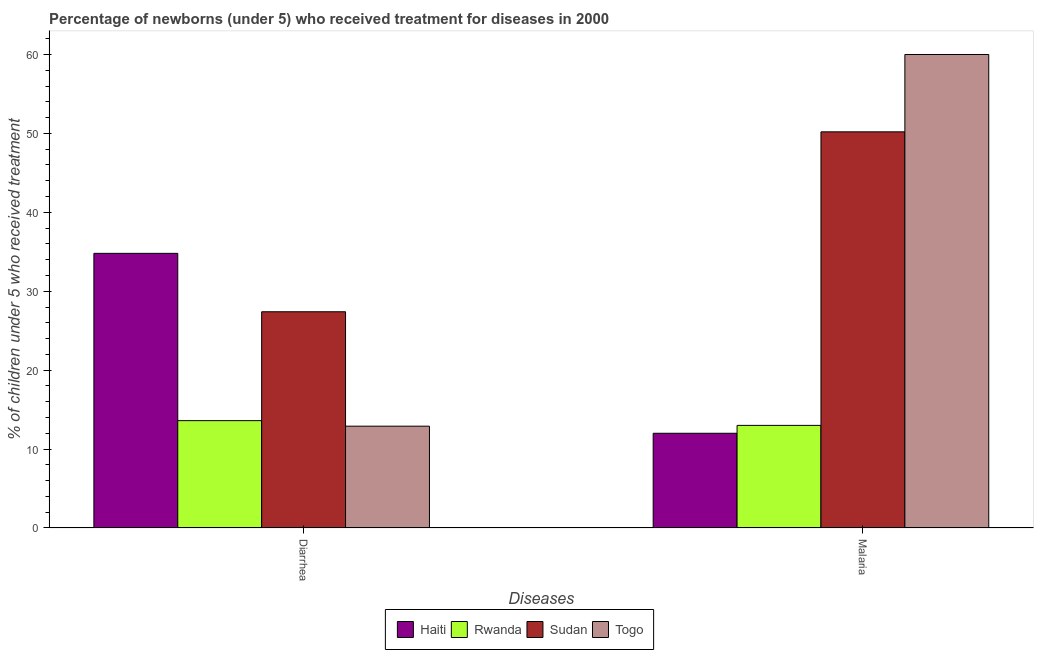Are the number of bars per tick equal to the number of legend labels?
Ensure brevity in your answer.  Yes. What is the label of the 1st group of bars from the left?
Ensure brevity in your answer.  Diarrhea. What is the percentage of children who received treatment for malaria in Togo?
Offer a terse response. 60. Across all countries, what is the maximum percentage of children who received treatment for malaria?
Offer a terse response. 60. In which country was the percentage of children who received treatment for diarrhoea maximum?
Keep it short and to the point. Haiti. In which country was the percentage of children who received treatment for diarrhoea minimum?
Give a very brief answer. Togo. What is the total percentage of children who received treatment for diarrhoea in the graph?
Give a very brief answer. 88.7. What is the difference between the percentage of children who received treatment for diarrhoea in Haiti and that in Sudan?
Provide a succinct answer. 7.4. What is the difference between the percentage of children who received treatment for diarrhoea in Sudan and the percentage of children who received treatment for malaria in Togo?
Offer a very short reply. -32.6. What is the average percentage of children who received treatment for malaria per country?
Offer a very short reply. 33.8. What is the difference between the percentage of children who received treatment for diarrhoea and percentage of children who received treatment for malaria in Rwanda?
Your response must be concise. 0.6. In how many countries, is the percentage of children who received treatment for malaria greater than 6 %?
Make the answer very short. 4. What is the ratio of the percentage of children who received treatment for diarrhoea in Sudan to that in Togo?
Ensure brevity in your answer.  2.12. In how many countries, is the percentage of children who received treatment for diarrhoea greater than the average percentage of children who received treatment for diarrhoea taken over all countries?
Provide a succinct answer. 2. What does the 1st bar from the left in Diarrhea represents?
Provide a succinct answer. Haiti. What does the 4th bar from the right in Malaria represents?
Your response must be concise. Haiti. How many countries are there in the graph?
Give a very brief answer. 4. Are the values on the major ticks of Y-axis written in scientific E-notation?
Your answer should be compact. No. Does the graph contain grids?
Offer a very short reply. No. What is the title of the graph?
Provide a short and direct response. Percentage of newborns (under 5) who received treatment for diseases in 2000. What is the label or title of the X-axis?
Provide a short and direct response. Diseases. What is the label or title of the Y-axis?
Provide a short and direct response. % of children under 5 who received treatment. What is the % of children under 5 who received treatment in Haiti in Diarrhea?
Provide a short and direct response. 34.8. What is the % of children under 5 who received treatment in Sudan in Diarrhea?
Provide a short and direct response. 27.4. What is the % of children under 5 who received treatment of Sudan in Malaria?
Your answer should be compact. 50.2. What is the % of children under 5 who received treatment in Togo in Malaria?
Give a very brief answer. 60. Across all Diseases, what is the maximum % of children under 5 who received treatment of Haiti?
Your response must be concise. 34.8. Across all Diseases, what is the maximum % of children under 5 who received treatment in Sudan?
Keep it short and to the point. 50.2. Across all Diseases, what is the maximum % of children under 5 who received treatment in Togo?
Offer a terse response. 60. Across all Diseases, what is the minimum % of children under 5 who received treatment of Haiti?
Ensure brevity in your answer.  12. Across all Diseases, what is the minimum % of children under 5 who received treatment of Rwanda?
Your answer should be compact. 13. Across all Diseases, what is the minimum % of children under 5 who received treatment of Sudan?
Your answer should be very brief. 27.4. What is the total % of children under 5 who received treatment in Haiti in the graph?
Your answer should be very brief. 46.8. What is the total % of children under 5 who received treatment of Rwanda in the graph?
Provide a succinct answer. 26.6. What is the total % of children under 5 who received treatment of Sudan in the graph?
Offer a terse response. 77.6. What is the total % of children under 5 who received treatment in Togo in the graph?
Offer a terse response. 72.9. What is the difference between the % of children under 5 who received treatment in Haiti in Diarrhea and that in Malaria?
Provide a succinct answer. 22.8. What is the difference between the % of children under 5 who received treatment of Rwanda in Diarrhea and that in Malaria?
Make the answer very short. 0.6. What is the difference between the % of children under 5 who received treatment in Sudan in Diarrhea and that in Malaria?
Provide a succinct answer. -22.8. What is the difference between the % of children under 5 who received treatment of Togo in Diarrhea and that in Malaria?
Your answer should be very brief. -47.1. What is the difference between the % of children under 5 who received treatment in Haiti in Diarrhea and the % of children under 5 who received treatment in Rwanda in Malaria?
Make the answer very short. 21.8. What is the difference between the % of children under 5 who received treatment of Haiti in Diarrhea and the % of children under 5 who received treatment of Sudan in Malaria?
Give a very brief answer. -15.4. What is the difference between the % of children under 5 who received treatment in Haiti in Diarrhea and the % of children under 5 who received treatment in Togo in Malaria?
Provide a succinct answer. -25.2. What is the difference between the % of children under 5 who received treatment of Rwanda in Diarrhea and the % of children under 5 who received treatment of Sudan in Malaria?
Offer a terse response. -36.6. What is the difference between the % of children under 5 who received treatment of Rwanda in Diarrhea and the % of children under 5 who received treatment of Togo in Malaria?
Your answer should be compact. -46.4. What is the difference between the % of children under 5 who received treatment of Sudan in Diarrhea and the % of children under 5 who received treatment of Togo in Malaria?
Your answer should be compact. -32.6. What is the average % of children under 5 who received treatment of Haiti per Diseases?
Your response must be concise. 23.4. What is the average % of children under 5 who received treatment in Sudan per Diseases?
Provide a succinct answer. 38.8. What is the average % of children under 5 who received treatment in Togo per Diseases?
Make the answer very short. 36.45. What is the difference between the % of children under 5 who received treatment of Haiti and % of children under 5 who received treatment of Rwanda in Diarrhea?
Provide a succinct answer. 21.2. What is the difference between the % of children under 5 who received treatment in Haiti and % of children under 5 who received treatment in Sudan in Diarrhea?
Ensure brevity in your answer.  7.4. What is the difference between the % of children under 5 who received treatment in Haiti and % of children under 5 who received treatment in Togo in Diarrhea?
Your response must be concise. 21.9. What is the difference between the % of children under 5 who received treatment in Rwanda and % of children under 5 who received treatment in Sudan in Diarrhea?
Your answer should be compact. -13.8. What is the difference between the % of children under 5 who received treatment in Haiti and % of children under 5 who received treatment in Rwanda in Malaria?
Ensure brevity in your answer.  -1. What is the difference between the % of children under 5 who received treatment of Haiti and % of children under 5 who received treatment of Sudan in Malaria?
Your answer should be compact. -38.2. What is the difference between the % of children under 5 who received treatment in Haiti and % of children under 5 who received treatment in Togo in Malaria?
Provide a succinct answer. -48. What is the difference between the % of children under 5 who received treatment of Rwanda and % of children under 5 who received treatment of Sudan in Malaria?
Offer a very short reply. -37.2. What is the difference between the % of children under 5 who received treatment in Rwanda and % of children under 5 who received treatment in Togo in Malaria?
Make the answer very short. -47. What is the ratio of the % of children under 5 who received treatment of Haiti in Diarrhea to that in Malaria?
Your answer should be compact. 2.9. What is the ratio of the % of children under 5 who received treatment in Rwanda in Diarrhea to that in Malaria?
Make the answer very short. 1.05. What is the ratio of the % of children under 5 who received treatment in Sudan in Diarrhea to that in Malaria?
Keep it short and to the point. 0.55. What is the ratio of the % of children under 5 who received treatment in Togo in Diarrhea to that in Malaria?
Provide a succinct answer. 0.21. What is the difference between the highest and the second highest % of children under 5 who received treatment in Haiti?
Provide a succinct answer. 22.8. What is the difference between the highest and the second highest % of children under 5 who received treatment of Rwanda?
Your answer should be very brief. 0.6. What is the difference between the highest and the second highest % of children under 5 who received treatment of Sudan?
Offer a terse response. 22.8. What is the difference between the highest and the second highest % of children under 5 who received treatment in Togo?
Your answer should be very brief. 47.1. What is the difference between the highest and the lowest % of children under 5 who received treatment of Haiti?
Provide a short and direct response. 22.8. What is the difference between the highest and the lowest % of children under 5 who received treatment in Sudan?
Provide a succinct answer. 22.8. What is the difference between the highest and the lowest % of children under 5 who received treatment of Togo?
Offer a terse response. 47.1. 